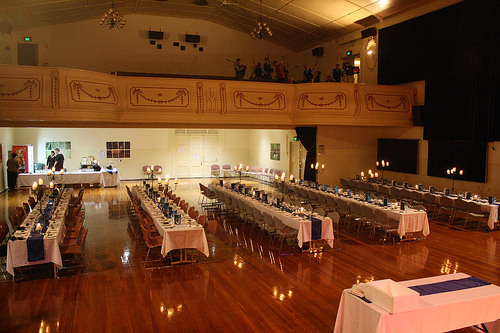<image>
Can you confirm if the speaker is on the wall? Yes. Looking at the image, I can see the speaker is positioned on top of the wall, with the wall providing support. 